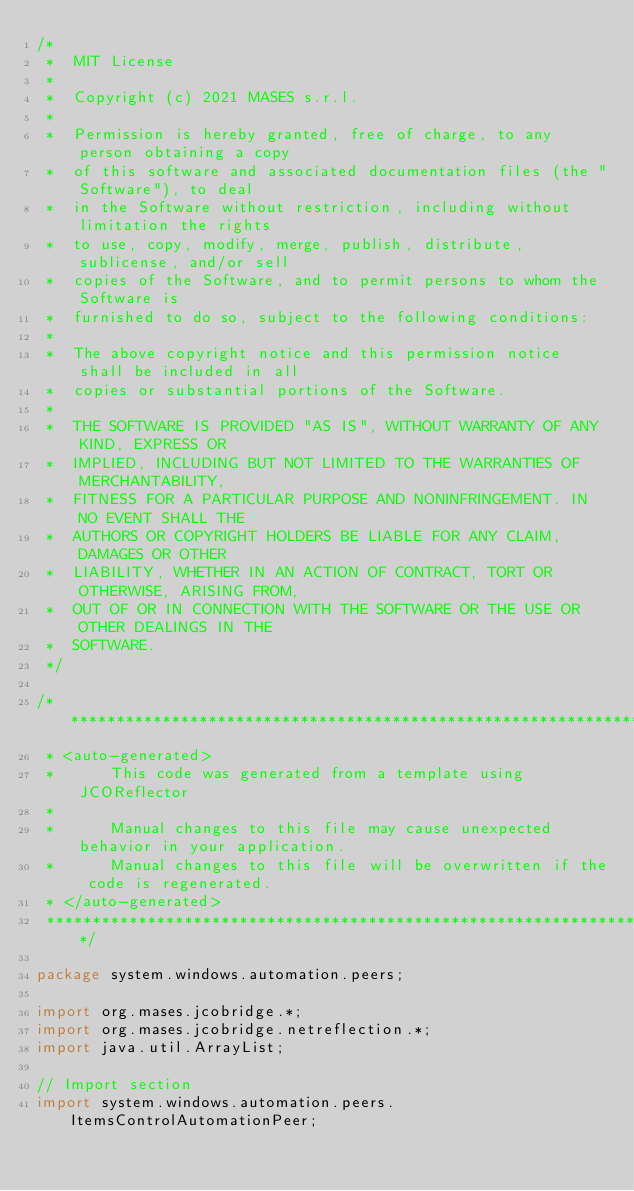<code> <loc_0><loc_0><loc_500><loc_500><_Java_>/*
 *  MIT License
 *
 *  Copyright (c) 2021 MASES s.r.l.
 *
 *  Permission is hereby granted, free of charge, to any person obtaining a copy
 *  of this software and associated documentation files (the "Software"), to deal
 *  in the Software without restriction, including without limitation the rights
 *  to use, copy, modify, merge, publish, distribute, sublicense, and/or sell
 *  copies of the Software, and to permit persons to whom the Software is
 *  furnished to do so, subject to the following conditions:
 *
 *  The above copyright notice and this permission notice shall be included in all
 *  copies or substantial portions of the Software.
 *
 *  THE SOFTWARE IS PROVIDED "AS IS", WITHOUT WARRANTY OF ANY KIND, EXPRESS OR
 *  IMPLIED, INCLUDING BUT NOT LIMITED TO THE WARRANTIES OF MERCHANTABILITY,
 *  FITNESS FOR A PARTICULAR PURPOSE AND NONINFRINGEMENT. IN NO EVENT SHALL THE
 *  AUTHORS OR COPYRIGHT HOLDERS BE LIABLE FOR ANY CLAIM, DAMAGES OR OTHER
 *  LIABILITY, WHETHER IN AN ACTION OF CONTRACT, TORT OR OTHERWISE, ARISING FROM,
 *  OUT OF OR IN CONNECTION WITH THE SOFTWARE OR THE USE OR OTHER DEALINGS IN THE
 *  SOFTWARE.
 */

/**************************************************************************************
 * <auto-generated>
 *      This code was generated from a template using JCOReflector
 * 
 *      Manual changes to this file may cause unexpected behavior in your application.
 *      Manual changes to this file will be overwritten if the code is regenerated.
 * </auto-generated>
 *************************************************************************************/

package system.windows.automation.peers;

import org.mases.jcobridge.*;
import org.mases.jcobridge.netreflection.*;
import java.util.ArrayList;

// Import section
import system.windows.automation.peers.ItemsControlAutomationPeer;</code> 